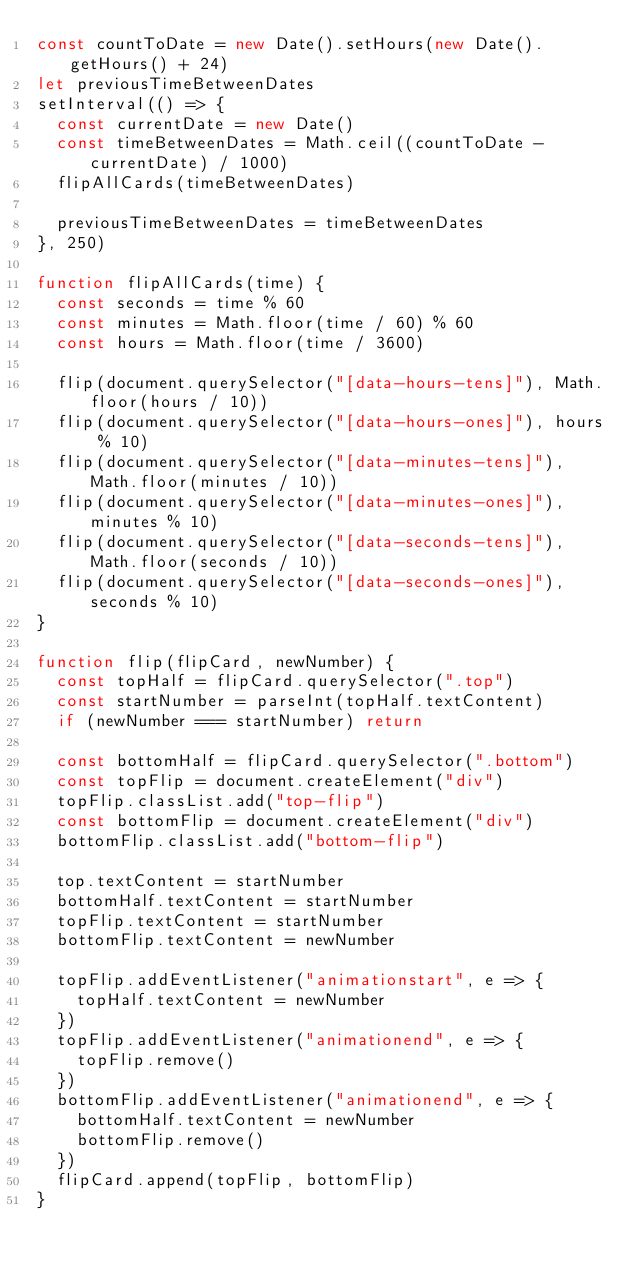Convert code to text. <code><loc_0><loc_0><loc_500><loc_500><_JavaScript_>const countToDate = new Date().setHours(new Date().getHours() + 24)
let previousTimeBetweenDates
setInterval(() => {
  const currentDate = new Date()
  const timeBetweenDates = Math.ceil((countToDate - currentDate) / 1000)
  flipAllCards(timeBetweenDates)

  previousTimeBetweenDates = timeBetweenDates
}, 250)

function flipAllCards(time) {
  const seconds = time % 60
  const minutes = Math.floor(time / 60) % 60
  const hours = Math.floor(time / 3600)

  flip(document.querySelector("[data-hours-tens]"), Math.floor(hours / 10))
  flip(document.querySelector("[data-hours-ones]"), hours % 10)
  flip(document.querySelector("[data-minutes-tens]"), Math.floor(minutes / 10))
  flip(document.querySelector("[data-minutes-ones]"), minutes % 10)
  flip(document.querySelector("[data-seconds-tens]"), Math.floor(seconds / 10))
  flip(document.querySelector("[data-seconds-ones]"), seconds % 10)
}

function flip(flipCard, newNumber) {
  const topHalf = flipCard.querySelector(".top")
  const startNumber = parseInt(topHalf.textContent)
  if (newNumber === startNumber) return

  const bottomHalf = flipCard.querySelector(".bottom")
  const topFlip = document.createElement("div")
  topFlip.classList.add("top-flip")
  const bottomFlip = document.createElement("div")
  bottomFlip.classList.add("bottom-flip")

  top.textContent = startNumber
  bottomHalf.textContent = startNumber
  topFlip.textContent = startNumber
  bottomFlip.textContent = newNumber

  topFlip.addEventListener("animationstart", e => {
    topHalf.textContent = newNumber
  })
  topFlip.addEventListener("animationend", e => {
    topFlip.remove()
  })
  bottomFlip.addEventListener("animationend", e => {
    bottomHalf.textContent = newNumber
    bottomFlip.remove()
  })
  flipCard.append(topFlip, bottomFlip)
}
</code> 